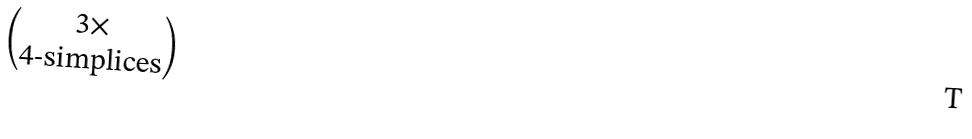Convert formula to latex. <formula><loc_0><loc_0><loc_500><loc_500>\begin{pmatrix} 3 \times \\ \text {4-simplices} \end{pmatrix}</formula> 